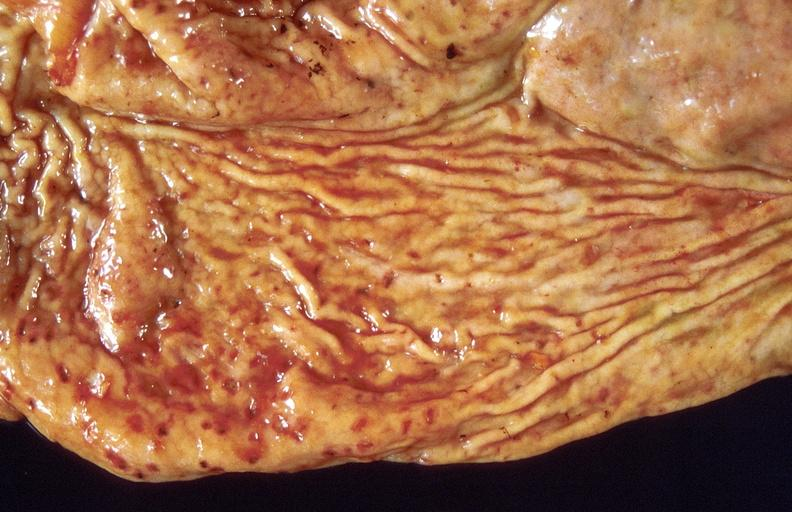where does this belong to?
Answer the question using a single word or phrase. Gastrointestinal system 